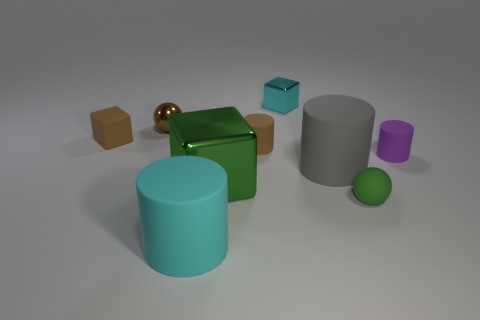Subtract 1 cylinders. How many cylinders are left? 3 Subtract all cubes. How many objects are left? 6 Add 7 cyan metallic things. How many cyan metallic things exist? 8 Subtract 1 brown cylinders. How many objects are left? 8 Subtract all red matte cubes. Subtract all big metallic things. How many objects are left? 8 Add 9 big green metallic objects. How many big green metallic objects are left? 10 